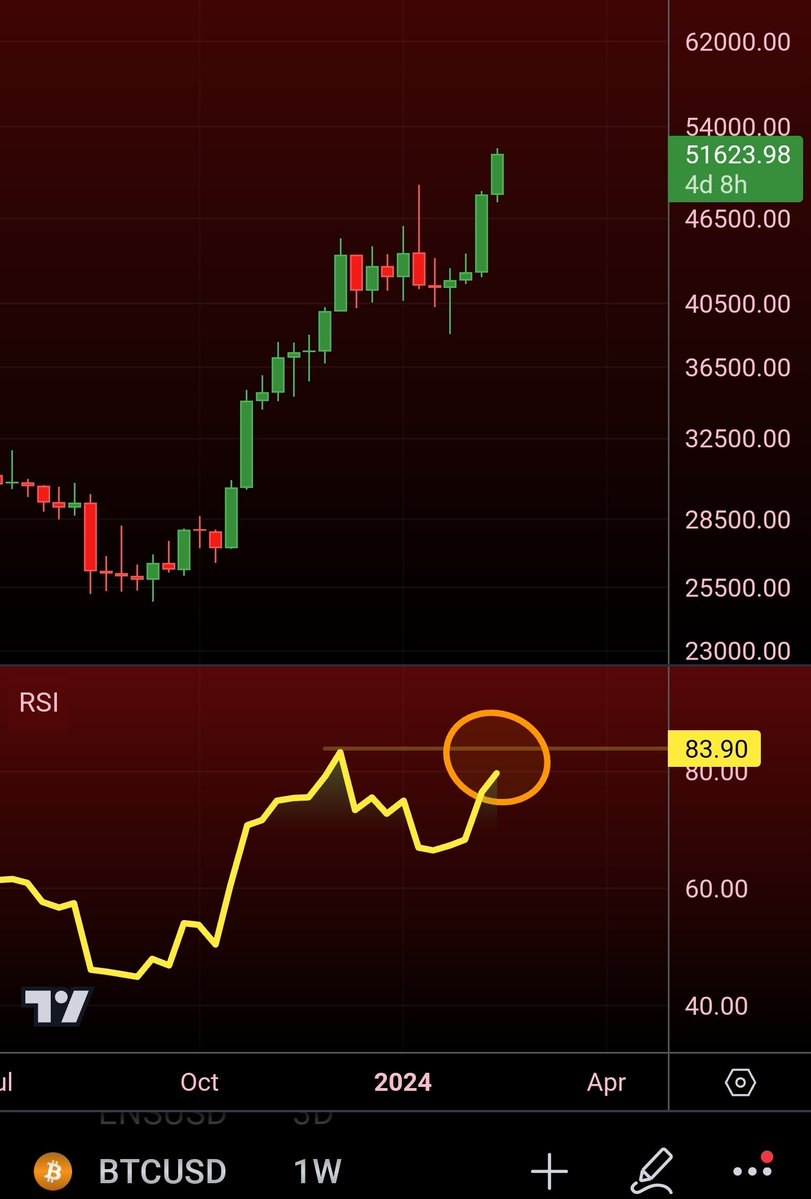should i buy or sell ? The RSI indicator is showing that the asset is overbought, which means that it may be a good time to sell. However, the price is also at a support level, which means that it may bounce back up. If you are looking for a short-term trade, then you may want to sell. However, if you are looking for a long-term investment, then you may want to hold onto the asset. 